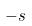Convert formula to latex. <formula><loc_0><loc_0><loc_500><loc_500>- s</formula> 